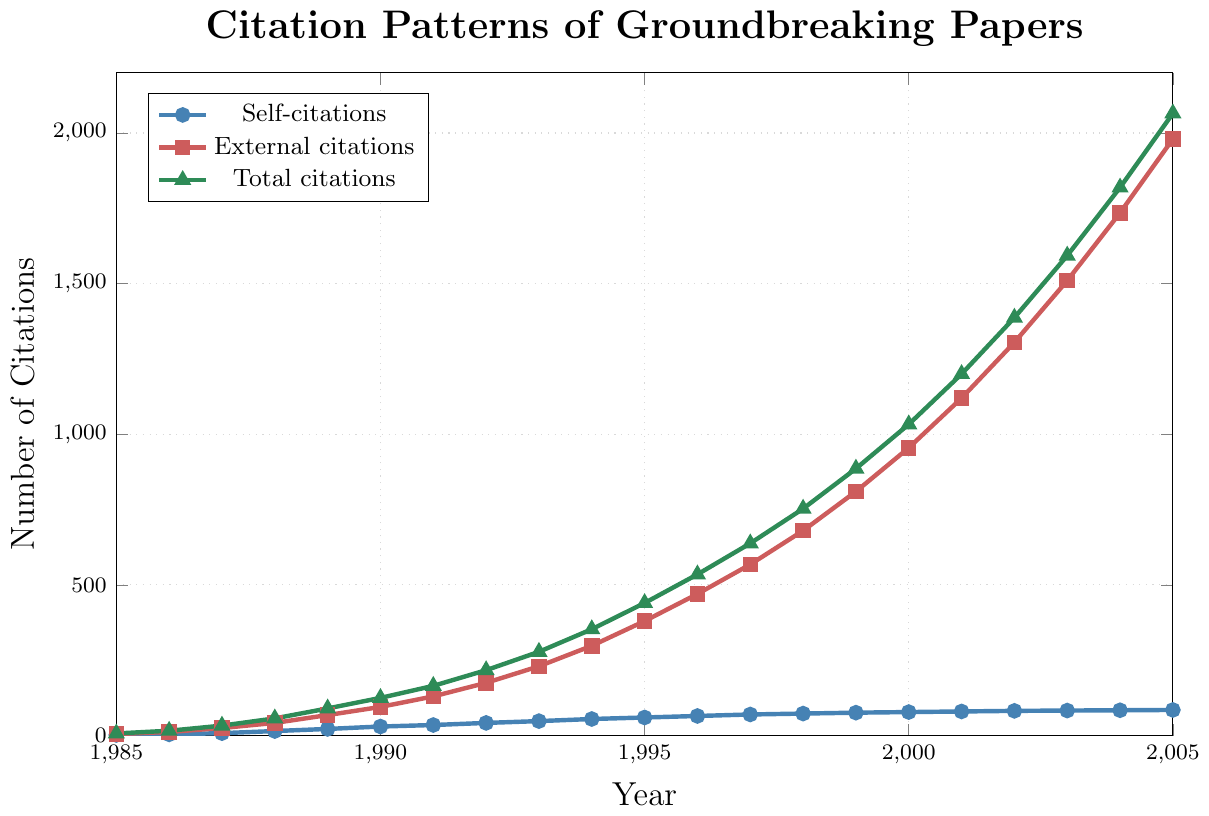What is the average number of self-citations from 1985 to 1990? To find the average, sum the self-citations from 1985 to 1990 (2 + 4 + 8 + 15 + 22 + 30) = 81. Then, divide the sum by the number of years (6) to get 81/6 = 13.5
Answer: 13.5 Which year had the highest number of total citations? Find the year with the highest point on the green "Total citations" line. The highest point is in 2005 with 2065 citations.
Answer: 2005 How many more external citations were there in 1990 compared to 1985? In 1990, there were 95 external citations, and in 1985, there were 5. The difference is 95 - 5 = 90.
Answer: 90 What is the difference in total citations between 2005 and 1990? Total citations in 2005 are 2065 and in 1990 are 125. The difference between them is 2065 - 125 = 1940.
Answer: 1940 In which year did self-citations first surpass 50? Check the blue "Self-citations" line to find the first year where self-citations are above 50. This happens in 1994 with 55 self-citations.
Answer: 1994 What is the trend in external citations from 1985 to 2005? The red "External citations" line shows a consistent upward trend from 5 in 1985 to 1980 in 2005.
Answer: Upward Which year had the smallest difference between self-citations and external citations? Calculate the difference for each year and find the smallest: 
1985: 5-2=3,
1986: 12-4=8,
1987: 25-8=17,
1988: 42-15=27,
1989: 68-22=46,
1990: 95-30=65,
1991: 130-35=95,
1992: 175-42=133,
1993: 230-48=182,
1994: 298-55=243,
1995: 380-60=320,
1996: 470-65=405,
1997: 568-70=498,
1998: 680-73=607,
1999: 810-76=734,
2000: 955-78=877,
2001: 1120-80=1040,
2002: 1305-82=1223,
2003: 1510-83=1427,
2004: 1735-84=1651,
2005: 1980-85=1895.
The smallest difference is 3 in 1985.
Answer: 1985 What percentage of total citations were self-citations in 1995? In 1995, self-citations were 60 and total citations were 440. The percentage is (60/440) * 100 = 13.64%.
Answer: 13.64% What is the increase in total citations from 1987 to 1997? Total citations in 1987 were 33 and in 1997 were 638. The increase is 638 - 33 = 605.
Answer: 605 Between which consecutive years was the largest increase in external citations observed? Calculate the year-over-year increase for external citations:
1986-1985: 12-5=7,
1987-1986: 25-12=13,
1988-1987: 42-25=17,
1989-1988: 68-42=26,
1990-1989: 95-68=27,
1991-1990: 130-95=35,
1992-1991: 175-130=45,
1993-1992: 230-175=55,
1994-1993: 298-230=68,
1995-1994: 380-298=82,
1996-1995: 470-380=90,
1997-1996: 568-470=98,
1998-1997: 680-568=112,
1999-1998: 810-680=130,
2000-1999: 955-810=145,
2001-2000: 1120-955=165,
2002-2001: 1305-1120=185,
2003-2002: 1510-1305=205,
2004-2003: 1735-1510=225,
2005-2004: 1980-1735=245.
The largest increase of 245 is observed between 2004 and 2005.
Answer: 2004 and 2005 